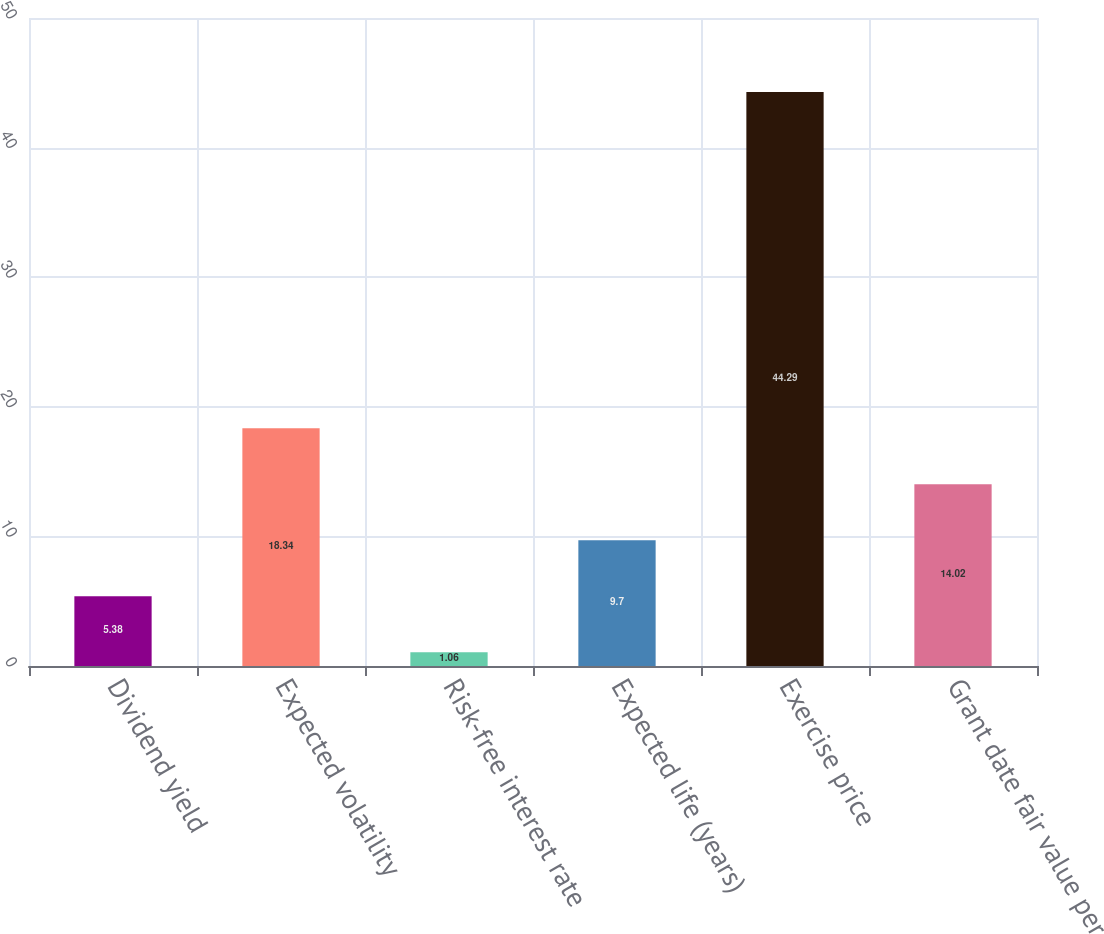Convert chart. <chart><loc_0><loc_0><loc_500><loc_500><bar_chart><fcel>Dividend yield<fcel>Expected volatility<fcel>Risk-free interest rate<fcel>Expected life (years)<fcel>Exercise price<fcel>Grant date fair value per<nl><fcel>5.38<fcel>18.34<fcel>1.06<fcel>9.7<fcel>44.29<fcel>14.02<nl></chart> 